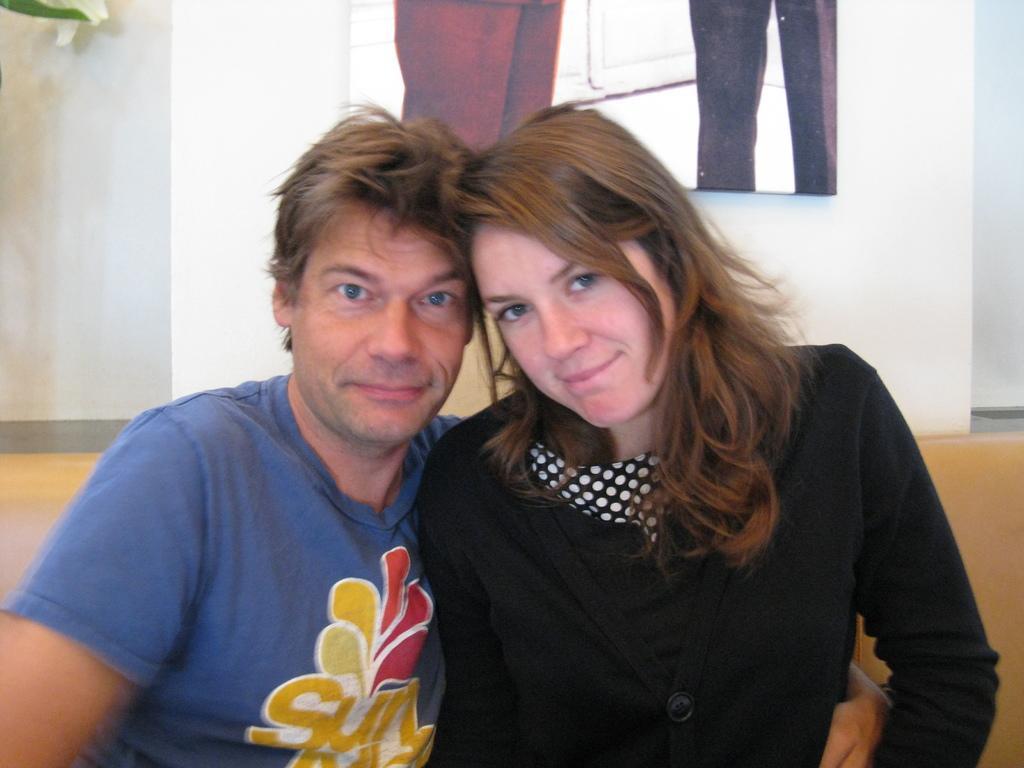Please provide a concise description of this image. In this image I can see two people. In the background, I can see the wall. 